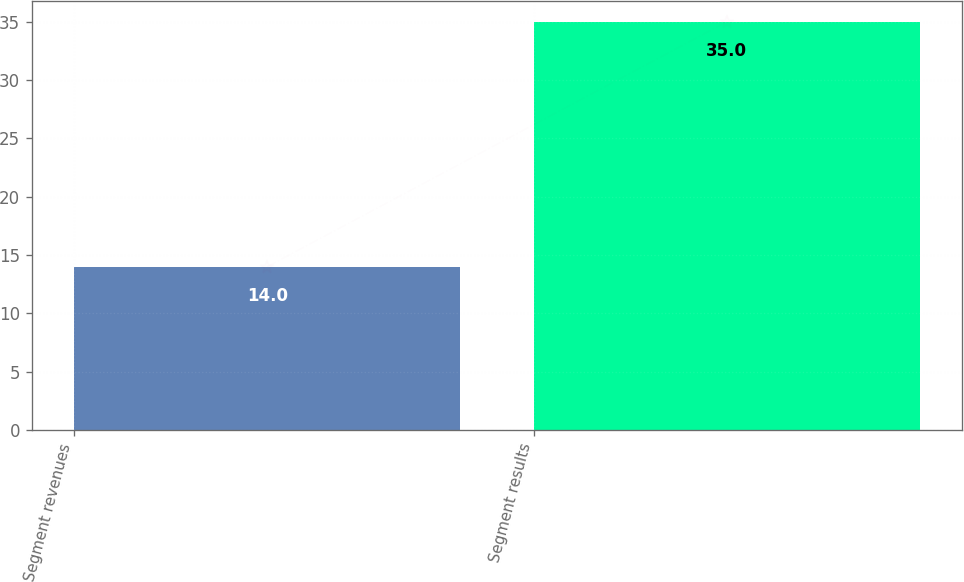Convert chart. <chart><loc_0><loc_0><loc_500><loc_500><bar_chart><fcel>Segment revenues<fcel>Segment results<nl><fcel>14<fcel>35<nl></chart> 